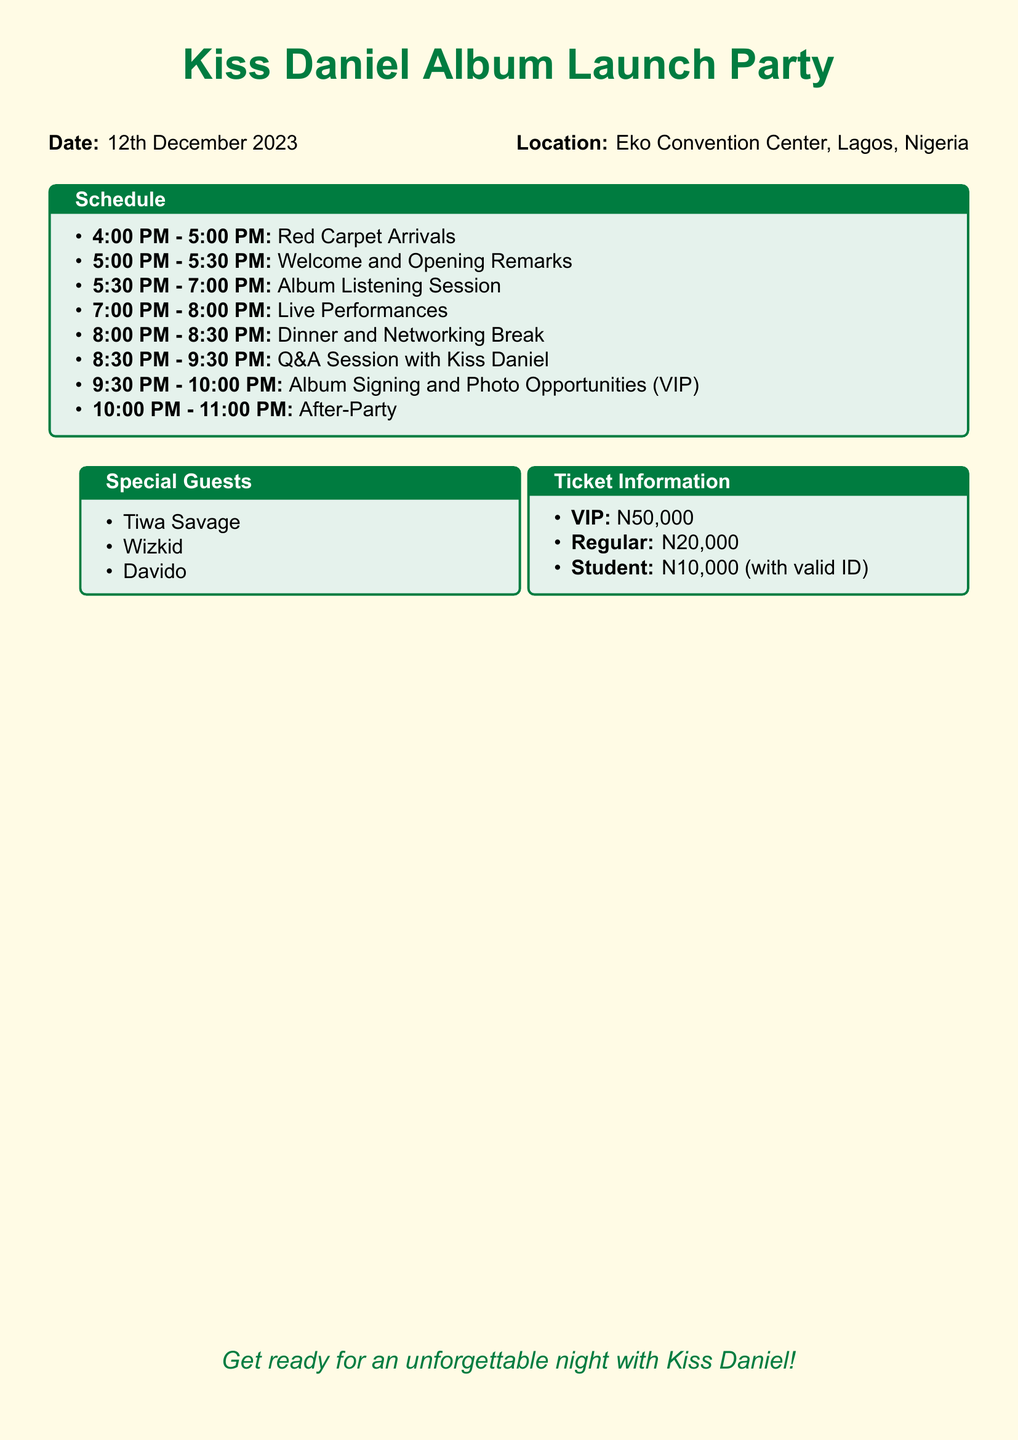What is the date of the album launch party? The date is specified prominently in the document, indicating when the event will take place.
Answer: 12th December 2023 Where will the album launch party take place? The location is clearly mentioned in the document, providing the venue for the celebration.
Answer: Eko Convention Center, Lagos, Nigeria What time does the Red Carpet Arrivals start? The schedule outlines the timings for each event, allowing for easy identification of specific start times.
Answer: 4:00 PM Who is one of the special guests at the event? The document lists special guests, allowing for the identification of notable attendees.
Answer: Tiwa Savage What is the cost of a VIP ticket? Ticket information details the prices for different ticket categories, enabling quick access to pricing details.
Answer: N50,000 How long is the Q&A session with Kiss Daniel? The schedule provides the exact duration for various segments, including this interactive session.
Answer: 1 hour How many activities are scheduled after dinner? By reviewing the schedule, we can summarize the activities following dinner.
Answer: 2 activities What type of ticket requires a valid ID? The ticket information specifies conditions under which certain categories of tickets are available.
Answer: Student 